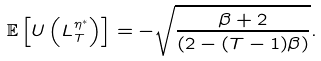Convert formula to latex. <formula><loc_0><loc_0><loc_500><loc_500>\mathbb { E } \left [ U \left ( L _ { T } ^ { { \eta } ^ { * } } \right ) \right ] = - \sqrt { \frac { \beta + 2 } { \left ( 2 - ( T - 1 ) \beta \right ) } } .</formula> 